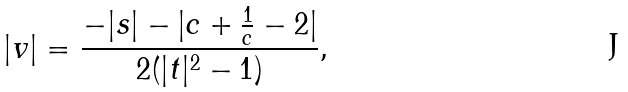Convert formula to latex. <formula><loc_0><loc_0><loc_500><loc_500>| v | = \frac { - | s | - | c + \frac { 1 } { c } - 2 | } { 2 ( | t | ^ { 2 } - 1 ) } ,</formula> 